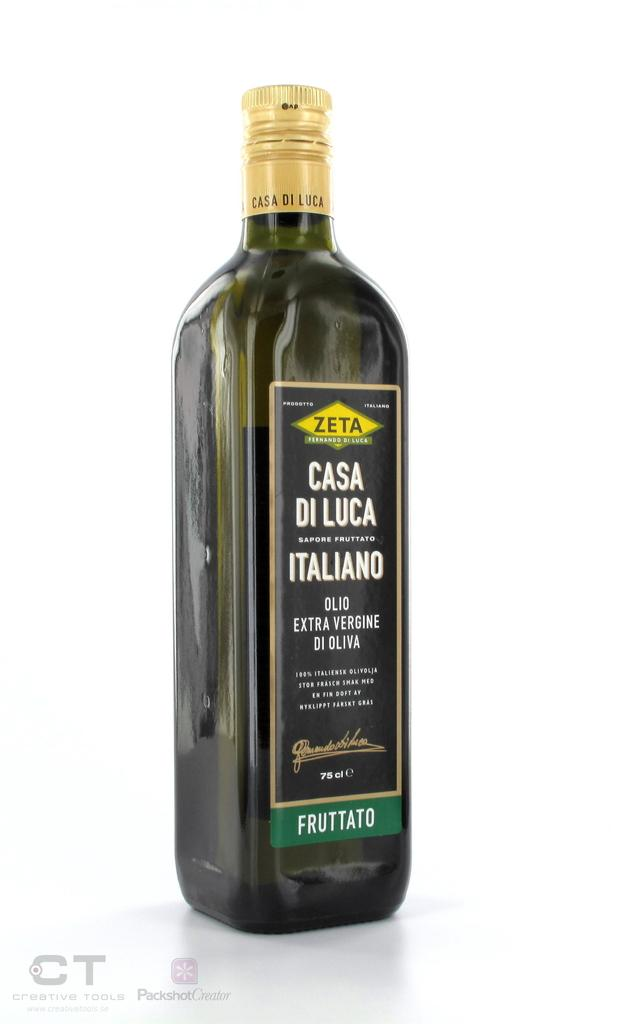<image>
Describe the image concisely. the word casa is on a wine bottle 